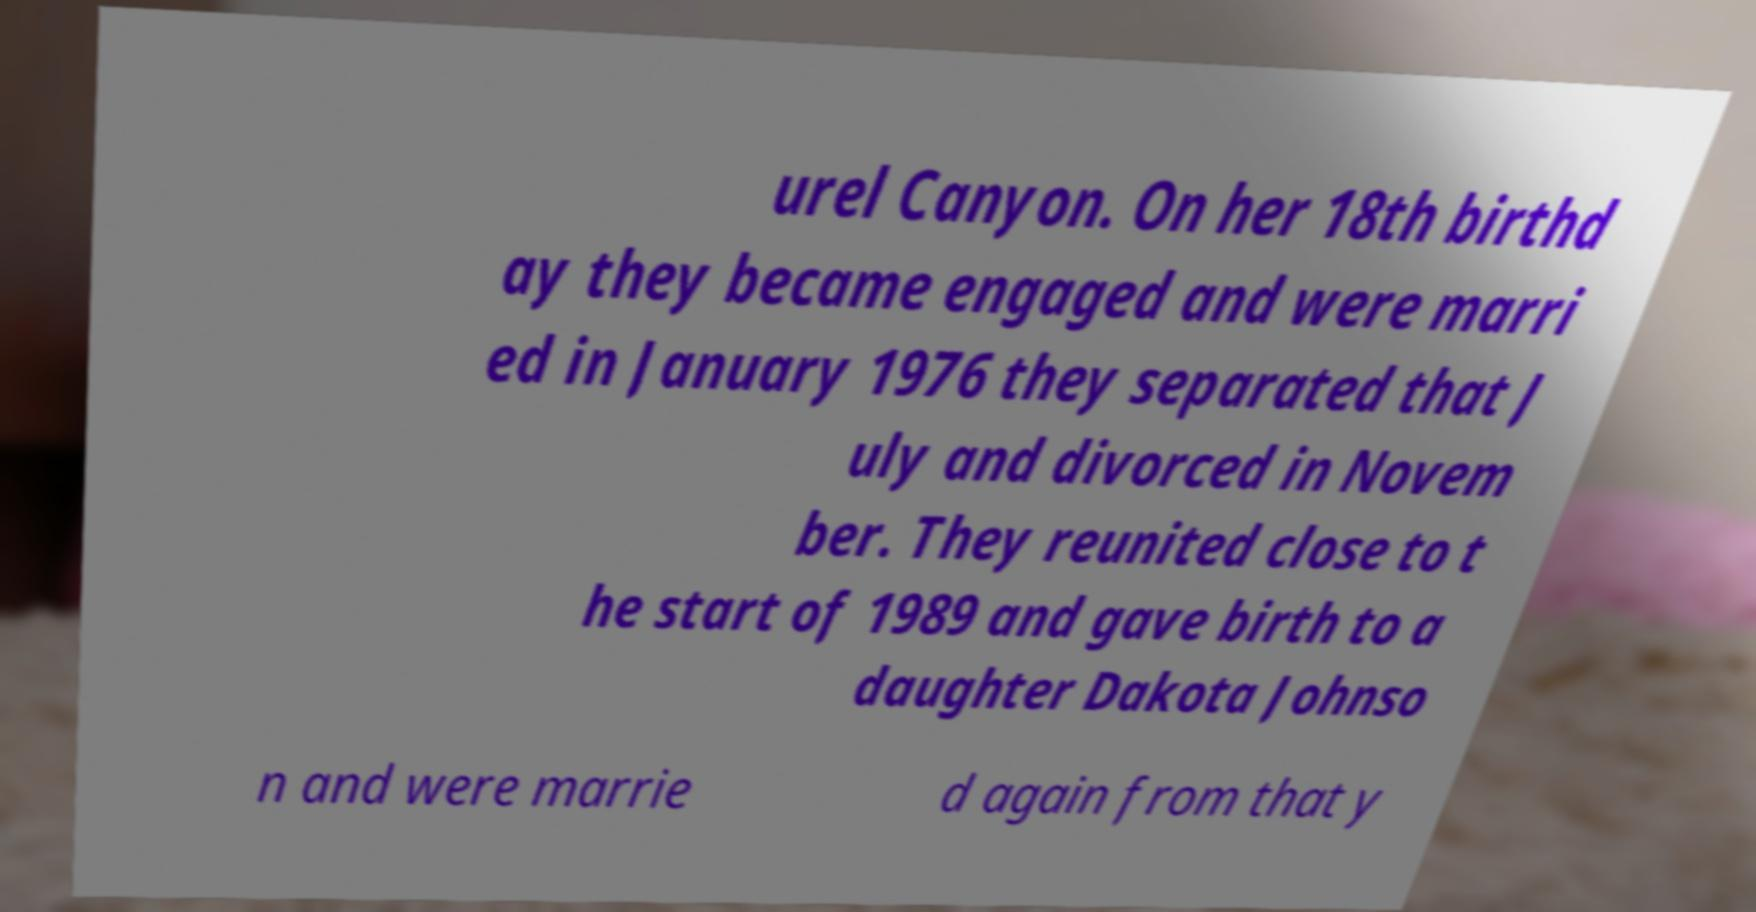Can you read and provide the text displayed in the image?This photo seems to have some interesting text. Can you extract and type it out for me? urel Canyon. On her 18th birthd ay they became engaged and were marri ed in January 1976 they separated that J uly and divorced in Novem ber. They reunited close to t he start of 1989 and gave birth to a daughter Dakota Johnso n and were marrie d again from that y 